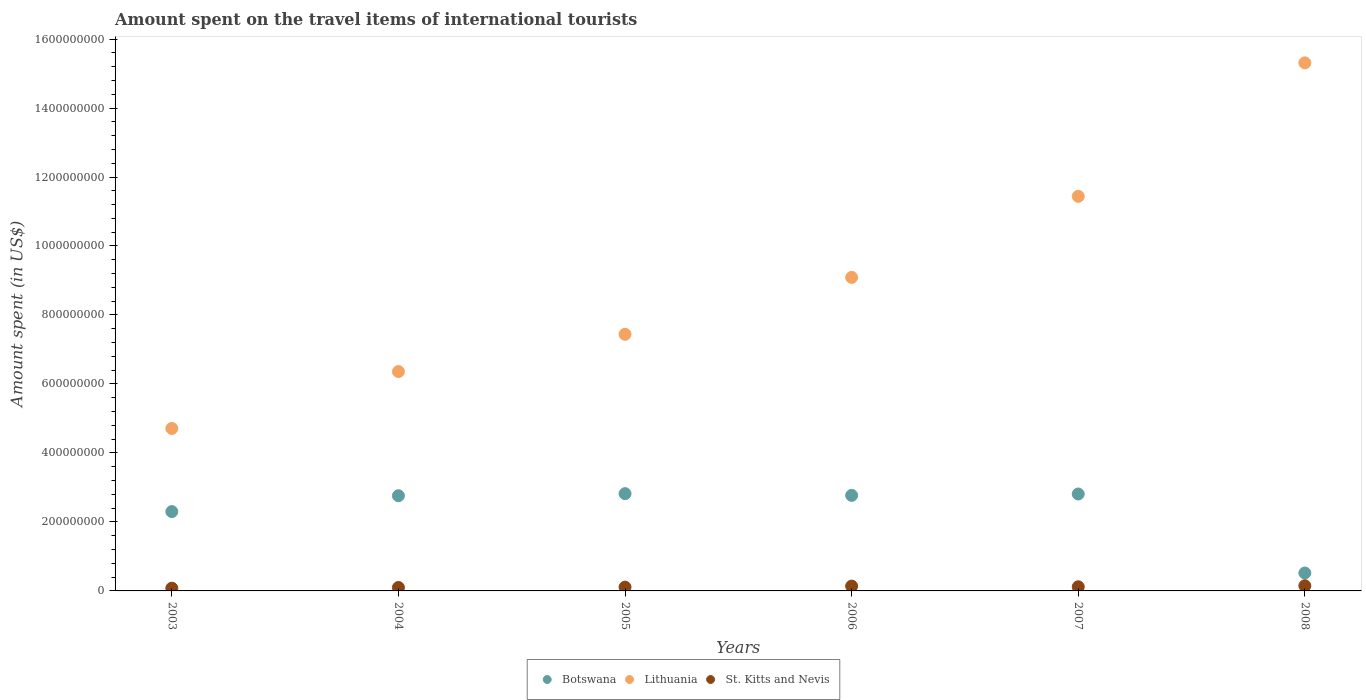Is the number of dotlines equal to the number of legend labels?
Provide a short and direct response. Yes. What is the amount spent on the travel items of international tourists in St. Kitts and Nevis in 2008?
Your response must be concise. 1.50e+07. Across all years, what is the maximum amount spent on the travel items of international tourists in Lithuania?
Your answer should be compact. 1.53e+09. Across all years, what is the minimum amount spent on the travel items of international tourists in Lithuania?
Provide a short and direct response. 4.71e+08. What is the total amount spent on the travel items of international tourists in Botswana in the graph?
Your answer should be compact. 1.40e+09. What is the difference between the amount spent on the travel items of international tourists in Lithuania in 2007 and that in 2008?
Offer a very short reply. -3.87e+08. What is the difference between the amount spent on the travel items of international tourists in Lithuania in 2004 and the amount spent on the travel items of international tourists in Botswana in 2005?
Offer a terse response. 3.54e+08. What is the average amount spent on the travel items of international tourists in Lithuania per year?
Keep it short and to the point. 9.06e+08. In the year 2007, what is the difference between the amount spent on the travel items of international tourists in Lithuania and amount spent on the travel items of international tourists in St. Kitts and Nevis?
Ensure brevity in your answer.  1.13e+09. In how many years, is the amount spent on the travel items of international tourists in Lithuania greater than 720000000 US$?
Your answer should be very brief. 4. What is the ratio of the amount spent on the travel items of international tourists in St. Kitts and Nevis in 2006 to that in 2008?
Make the answer very short. 0.93. Is the difference between the amount spent on the travel items of international tourists in Lithuania in 2003 and 2006 greater than the difference between the amount spent on the travel items of international tourists in St. Kitts and Nevis in 2003 and 2006?
Make the answer very short. No. What is the difference between the highest and the lowest amount spent on the travel items of international tourists in St. Kitts and Nevis?
Your answer should be very brief. 7.00e+06. How many dotlines are there?
Provide a succinct answer. 3. Are the values on the major ticks of Y-axis written in scientific E-notation?
Offer a very short reply. No. Does the graph contain any zero values?
Provide a short and direct response. No. Does the graph contain grids?
Offer a terse response. No. Where does the legend appear in the graph?
Offer a terse response. Bottom center. How many legend labels are there?
Make the answer very short. 3. How are the legend labels stacked?
Keep it short and to the point. Horizontal. What is the title of the graph?
Offer a terse response. Amount spent on the travel items of international tourists. What is the label or title of the Y-axis?
Make the answer very short. Amount spent (in US$). What is the Amount spent (in US$) of Botswana in 2003?
Give a very brief answer. 2.30e+08. What is the Amount spent (in US$) in Lithuania in 2003?
Make the answer very short. 4.71e+08. What is the Amount spent (in US$) of Botswana in 2004?
Give a very brief answer. 2.76e+08. What is the Amount spent (in US$) of Lithuania in 2004?
Keep it short and to the point. 6.36e+08. What is the Amount spent (in US$) of Botswana in 2005?
Provide a succinct answer. 2.82e+08. What is the Amount spent (in US$) in Lithuania in 2005?
Offer a very short reply. 7.44e+08. What is the Amount spent (in US$) in St. Kitts and Nevis in 2005?
Provide a short and direct response. 1.10e+07. What is the Amount spent (in US$) in Botswana in 2006?
Provide a short and direct response. 2.77e+08. What is the Amount spent (in US$) of Lithuania in 2006?
Give a very brief answer. 9.09e+08. What is the Amount spent (in US$) in St. Kitts and Nevis in 2006?
Give a very brief answer. 1.40e+07. What is the Amount spent (in US$) in Botswana in 2007?
Ensure brevity in your answer.  2.81e+08. What is the Amount spent (in US$) of Lithuania in 2007?
Provide a short and direct response. 1.14e+09. What is the Amount spent (in US$) in Botswana in 2008?
Your answer should be compact. 5.20e+07. What is the Amount spent (in US$) in Lithuania in 2008?
Keep it short and to the point. 1.53e+09. What is the Amount spent (in US$) in St. Kitts and Nevis in 2008?
Provide a succinct answer. 1.50e+07. Across all years, what is the maximum Amount spent (in US$) in Botswana?
Make the answer very short. 2.82e+08. Across all years, what is the maximum Amount spent (in US$) in Lithuania?
Your answer should be very brief. 1.53e+09. Across all years, what is the maximum Amount spent (in US$) of St. Kitts and Nevis?
Provide a short and direct response. 1.50e+07. Across all years, what is the minimum Amount spent (in US$) of Botswana?
Make the answer very short. 5.20e+07. Across all years, what is the minimum Amount spent (in US$) in Lithuania?
Make the answer very short. 4.71e+08. Across all years, what is the minimum Amount spent (in US$) in St. Kitts and Nevis?
Make the answer very short. 8.00e+06. What is the total Amount spent (in US$) in Botswana in the graph?
Provide a succinct answer. 1.40e+09. What is the total Amount spent (in US$) in Lithuania in the graph?
Offer a terse response. 5.44e+09. What is the total Amount spent (in US$) of St. Kitts and Nevis in the graph?
Provide a short and direct response. 7.00e+07. What is the difference between the Amount spent (in US$) in Botswana in 2003 and that in 2004?
Provide a succinct answer. -4.60e+07. What is the difference between the Amount spent (in US$) of Lithuania in 2003 and that in 2004?
Your answer should be compact. -1.65e+08. What is the difference between the Amount spent (in US$) of St. Kitts and Nevis in 2003 and that in 2004?
Your response must be concise. -2.00e+06. What is the difference between the Amount spent (in US$) of Botswana in 2003 and that in 2005?
Provide a succinct answer. -5.20e+07. What is the difference between the Amount spent (in US$) of Lithuania in 2003 and that in 2005?
Your response must be concise. -2.73e+08. What is the difference between the Amount spent (in US$) in Botswana in 2003 and that in 2006?
Provide a short and direct response. -4.70e+07. What is the difference between the Amount spent (in US$) of Lithuania in 2003 and that in 2006?
Provide a short and direct response. -4.38e+08. What is the difference between the Amount spent (in US$) of St. Kitts and Nevis in 2003 and that in 2006?
Give a very brief answer. -6.00e+06. What is the difference between the Amount spent (in US$) in Botswana in 2003 and that in 2007?
Keep it short and to the point. -5.10e+07. What is the difference between the Amount spent (in US$) of Lithuania in 2003 and that in 2007?
Your response must be concise. -6.73e+08. What is the difference between the Amount spent (in US$) in St. Kitts and Nevis in 2003 and that in 2007?
Your answer should be compact. -4.00e+06. What is the difference between the Amount spent (in US$) of Botswana in 2003 and that in 2008?
Make the answer very short. 1.78e+08. What is the difference between the Amount spent (in US$) of Lithuania in 2003 and that in 2008?
Your answer should be compact. -1.06e+09. What is the difference between the Amount spent (in US$) in St. Kitts and Nevis in 2003 and that in 2008?
Your response must be concise. -7.00e+06. What is the difference between the Amount spent (in US$) of Botswana in 2004 and that in 2005?
Provide a short and direct response. -6.00e+06. What is the difference between the Amount spent (in US$) of Lithuania in 2004 and that in 2005?
Provide a succinct answer. -1.08e+08. What is the difference between the Amount spent (in US$) in St. Kitts and Nevis in 2004 and that in 2005?
Ensure brevity in your answer.  -1.00e+06. What is the difference between the Amount spent (in US$) in Lithuania in 2004 and that in 2006?
Make the answer very short. -2.73e+08. What is the difference between the Amount spent (in US$) in St. Kitts and Nevis in 2004 and that in 2006?
Give a very brief answer. -4.00e+06. What is the difference between the Amount spent (in US$) of Botswana in 2004 and that in 2007?
Offer a terse response. -5.00e+06. What is the difference between the Amount spent (in US$) in Lithuania in 2004 and that in 2007?
Make the answer very short. -5.08e+08. What is the difference between the Amount spent (in US$) of St. Kitts and Nevis in 2004 and that in 2007?
Your answer should be compact. -2.00e+06. What is the difference between the Amount spent (in US$) in Botswana in 2004 and that in 2008?
Offer a very short reply. 2.24e+08. What is the difference between the Amount spent (in US$) of Lithuania in 2004 and that in 2008?
Provide a succinct answer. -8.95e+08. What is the difference between the Amount spent (in US$) of St. Kitts and Nevis in 2004 and that in 2008?
Provide a short and direct response. -5.00e+06. What is the difference between the Amount spent (in US$) of Botswana in 2005 and that in 2006?
Your answer should be compact. 5.00e+06. What is the difference between the Amount spent (in US$) of Lithuania in 2005 and that in 2006?
Give a very brief answer. -1.65e+08. What is the difference between the Amount spent (in US$) in Botswana in 2005 and that in 2007?
Your answer should be very brief. 1.00e+06. What is the difference between the Amount spent (in US$) of Lithuania in 2005 and that in 2007?
Ensure brevity in your answer.  -4.00e+08. What is the difference between the Amount spent (in US$) in Botswana in 2005 and that in 2008?
Offer a terse response. 2.30e+08. What is the difference between the Amount spent (in US$) in Lithuania in 2005 and that in 2008?
Give a very brief answer. -7.87e+08. What is the difference between the Amount spent (in US$) of St. Kitts and Nevis in 2005 and that in 2008?
Ensure brevity in your answer.  -4.00e+06. What is the difference between the Amount spent (in US$) of Botswana in 2006 and that in 2007?
Your response must be concise. -4.00e+06. What is the difference between the Amount spent (in US$) in Lithuania in 2006 and that in 2007?
Provide a short and direct response. -2.35e+08. What is the difference between the Amount spent (in US$) of Botswana in 2006 and that in 2008?
Give a very brief answer. 2.25e+08. What is the difference between the Amount spent (in US$) of Lithuania in 2006 and that in 2008?
Make the answer very short. -6.22e+08. What is the difference between the Amount spent (in US$) of St. Kitts and Nevis in 2006 and that in 2008?
Your answer should be very brief. -1.00e+06. What is the difference between the Amount spent (in US$) of Botswana in 2007 and that in 2008?
Your answer should be very brief. 2.29e+08. What is the difference between the Amount spent (in US$) of Lithuania in 2007 and that in 2008?
Make the answer very short. -3.87e+08. What is the difference between the Amount spent (in US$) of St. Kitts and Nevis in 2007 and that in 2008?
Offer a terse response. -3.00e+06. What is the difference between the Amount spent (in US$) in Botswana in 2003 and the Amount spent (in US$) in Lithuania in 2004?
Provide a succinct answer. -4.06e+08. What is the difference between the Amount spent (in US$) in Botswana in 2003 and the Amount spent (in US$) in St. Kitts and Nevis in 2004?
Provide a succinct answer. 2.20e+08. What is the difference between the Amount spent (in US$) in Lithuania in 2003 and the Amount spent (in US$) in St. Kitts and Nevis in 2004?
Provide a short and direct response. 4.61e+08. What is the difference between the Amount spent (in US$) of Botswana in 2003 and the Amount spent (in US$) of Lithuania in 2005?
Your answer should be very brief. -5.14e+08. What is the difference between the Amount spent (in US$) in Botswana in 2003 and the Amount spent (in US$) in St. Kitts and Nevis in 2005?
Your answer should be very brief. 2.19e+08. What is the difference between the Amount spent (in US$) in Lithuania in 2003 and the Amount spent (in US$) in St. Kitts and Nevis in 2005?
Offer a terse response. 4.60e+08. What is the difference between the Amount spent (in US$) in Botswana in 2003 and the Amount spent (in US$) in Lithuania in 2006?
Provide a short and direct response. -6.79e+08. What is the difference between the Amount spent (in US$) in Botswana in 2003 and the Amount spent (in US$) in St. Kitts and Nevis in 2006?
Your answer should be very brief. 2.16e+08. What is the difference between the Amount spent (in US$) of Lithuania in 2003 and the Amount spent (in US$) of St. Kitts and Nevis in 2006?
Your answer should be compact. 4.57e+08. What is the difference between the Amount spent (in US$) in Botswana in 2003 and the Amount spent (in US$) in Lithuania in 2007?
Your answer should be compact. -9.14e+08. What is the difference between the Amount spent (in US$) in Botswana in 2003 and the Amount spent (in US$) in St. Kitts and Nevis in 2007?
Your answer should be compact. 2.18e+08. What is the difference between the Amount spent (in US$) of Lithuania in 2003 and the Amount spent (in US$) of St. Kitts and Nevis in 2007?
Offer a very short reply. 4.59e+08. What is the difference between the Amount spent (in US$) of Botswana in 2003 and the Amount spent (in US$) of Lithuania in 2008?
Your answer should be compact. -1.30e+09. What is the difference between the Amount spent (in US$) of Botswana in 2003 and the Amount spent (in US$) of St. Kitts and Nevis in 2008?
Provide a short and direct response. 2.15e+08. What is the difference between the Amount spent (in US$) of Lithuania in 2003 and the Amount spent (in US$) of St. Kitts and Nevis in 2008?
Make the answer very short. 4.56e+08. What is the difference between the Amount spent (in US$) in Botswana in 2004 and the Amount spent (in US$) in Lithuania in 2005?
Give a very brief answer. -4.68e+08. What is the difference between the Amount spent (in US$) of Botswana in 2004 and the Amount spent (in US$) of St. Kitts and Nevis in 2005?
Give a very brief answer. 2.65e+08. What is the difference between the Amount spent (in US$) in Lithuania in 2004 and the Amount spent (in US$) in St. Kitts and Nevis in 2005?
Ensure brevity in your answer.  6.25e+08. What is the difference between the Amount spent (in US$) of Botswana in 2004 and the Amount spent (in US$) of Lithuania in 2006?
Offer a terse response. -6.33e+08. What is the difference between the Amount spent (in US$) in Botswana in 2004 and the Amount spent (in US$) in St. Kitts and Nevis in 2006?
Offer a very short reply. 2.62e+08. What is the difference between the Amount spent (in US$) in Lithuania in 2004 and the Amount spent (in US$) in St. Kitts and Nevis in 2006?
Give a very brief answer. 6.22e+08. What is the difference between the Amount spent (in US$) in Botswana in 2004 and the Amount spent (in US$) in Lithuania in 2007?
Offer a very short reply. -8.68e+08. What is the difference between the Amount spent (in US$) of Botswana in 2004 and the Amount spent (in US$) of St. Kitts and Nevis in 2007?
Provide a succinct answer. 2.64e+08. What is the difference between the Amount spent (in US$) of Lithuania in 2004 and the Amount spent (in US$) of St. Kitts and Nevis in 2007?
Offer a terse response. 6.24e+08. What is the difference between the Amount spent (in US$) in Botswana in 2004 and the Amount spent (in US$) in Lithuania in 2008?
Provide a succinct answer. -1.26e+09. What is the difference between the Amount spent (in US$) in Botswana in 2004 and the Amount spent (in US$) in St. Kitts and Nevis in 2008?
Ensure brevity in your answer.  2.61e+08. What is the difference between the Amount spent (in US$) of Lithuania in 2004 and the Amount spent (in US$) of St. Kitts and Nevis in 2008?
Your answer should be compact. 6.21e+08. What is the difference between the Amount spent (in US$) in Botswana in 2005 and the Amount spent (in US$) in Lithuania in 2006?
Offer a terse response. -6.27e+08. What is the difference between the Amount spent (in US$) of Botswana in 2005 and the Amount spent (in US$) of St. Kitts and Nevis in 2006?
Offer a terse response. 2.68e+08. What is the difference between the Amount spent (in US$) in Lithuania in 2005 and the Amount spent (in US$) in St. Kitts and Nevis in 2006?
Offer a terse response. 7.30e+08. What is the difference between the Amount spent (in US$) of Botswana in 2005 and the Amount spent (in US$) of Lithuania in 2007?
Your answer should be very brief. -8.62e+08. What is the difference between the Amount spent (in US$) of Botswana in 2005 and the Amount spent (in US$) of St. Kitts and Nevis in 2007?
Keep it short and to the point. 2.70e+08. What is the difference between the Amount spent (in US$) of Lithuania in 2005 and the Amount spent (in US$) of St. Kitts and Nevis in 2007?
Give a very brief answer. 7.32e+08. What is the difference between the Amount spent (in US$) of Botswana in 2005 and the Amount spent (in US$) of Lithuania in 2008?
Your answer should be very brief. -1.25e+09. What is the difference between the Amount spent (in US$) of Botswana in 2005 and the Amount spent (in US$) of St. Kitts and Nevis in 2008?
Provide a succinct answer. 2.67e+08. What is the difference between the Amount spent (in US$) of Lithuania in 2005 and the Amount spent (in US$) of St. Kitts and Nevis in 2008?
Ensure brevity in your answer.  7.29e+08. What is the difference between the Amount spent (in US$) in Botswana in 2006 and the Amount spent (in US$) in Lithuania in 2007?
Your response must be concise. -8.67e+08. What is the difference between the Amount spent (in US$) in Botswana in 2006 and the Amount spent (in US$) in St. Kitts and Nevis in 2007?
Give a very brief answer. 2.65e+08. What is the difference between the Amount spent (in US$) in Lithuania in 2006 and the Amount spent (in US$) in St. Kitts and Nevis in 2007?
Your answer should be compact. 8.97e+08. What is the difference between the Amount spent (in US$) of Botswana in 2006 and the Amount spent (in US$) of Lithuania in 2008?
Give a very brief answer. -1.25e+09. What is the difference between the Amount spent (in US$) of Botswana in 2006 and the Amount spent (in US$) of St. Kitts and Nevis in 2008?
Give a very brief answer. 2.62e+08. What is the difference between the Amount spent (in US$) in Lithuania in 2006 and the Amount spent (in US$) in St. Kitts and Nevis in 2008?
Offer a very short reply. 8.94e+08. What is the difference between the Amount spent (in US$) in Botswana in 2007 and the Amount spent (in US$) in Lithuania in 2008?
Your answer should be compact. -1.25e+09. What is the difference between the Amount spent (in US$) of Botswana in 2007 and the Amount spent (in US$) of St. Kitts and Nevis in 2008?
Make the answer very short. 2.66e+08. What is the difference between the Amount spent (in US$) in Lithuania in 2007 and the Amount spent (in US$) in St. Kitts and Nevis in 2008?
Make the answer very short. 1.13e+09. What is the average Amount spent (in US$) in Botswana per year?
Provide a short and direct response. 2.33e+08. What is the average Amount spent (in US$) of Lithuania per year?
Offer a very short reply. 9.06e+08. What is the average Amount spent (in US$) in St. Kitts and Nevis per year?
Make the answer very short. 1.17e+07. In the year 2003, what is the difference between the Amount spent (in US$) of Botswana and Amount spent (in US$) of Lithuania?
Make the answer very short. -2.41e+08. In the year 2003, what is the difference between the Amount spent (in US$) of Botswana and Amount spent (in US$) of St. Kitts and Nevis?
Your answer should be very brief. 2.22e+08. In the year 2003, what is the difference between the Amount spent (in US$) in Lithuania and Amount spent (in US$) in St. Kitts and Nevis?
Give a very brief answer. 4.63e+08. In the year 2004, what is the difference between the Amount spent (in US$) in Botswana and Amount spent (in US$) in Lithuania?
Provide a succinct answer. -3.60e+08. In the year 2004, what is the difference between the Amount spent (in US$) in Botswana and Amount spent (in US$) in St. Kitts and Nevis?
Ensure brevity in your answer.  2.66e+08. In the year 2004, what is the difference between the Amount spent (in US$) in Lithuania and Amount spent (in US$) in St. Kitts and Nevis?
Your answer should be very brief. 6.26e+08. In the year 2005, what is the difference between the Amount spent (in US$) in Botswana and Amount spent (in US$) in Lithuania?
Provide a short and direct response. -4.62e+08. In the year 2005, what is the difference between the Amount spent (in US$) in Botswana and Amount spent (in US$) in St. Kitts and Nevis?
Offer a very short reply. 2.71e+08. In the year 2005, what is the difference between the Amount spent (in US$) in Lithuania and Amount spent (in US$) in St. Kitts and Nevis?
Offer a terse response. 7.33e+08. In the year 2006, what is the difference between the Amount spent (in US$) in Botswana and Amount spent (in US$) in Lithuania?
Offer a terse response. -6.32e+08. In the year 2006, what is the difference between the Amount spent (in US$) of Botswana and Amount spent (in US$) of St. Kitts and Nevis?
Keep it short and to the point. 2.63e+08. In the year 2006, what is the difference between the Amount spent (in US$) of Lithuania and Amount spent (in US$) of St. Kitts and Nevis?
Provide a succinct answer. 8.95e+08. In the year 2007, what is the difference between the Amount spent (in US$) in Botswana and Amount spent (in US$) in Lithuania?
Ensure brevity in your answer.  -8.63e+08. In the year 2007, what is the difference between the Amount spent (in US$) in Botswana and Amount spent (in US$) in St. Kitts and Nevis?
Provide a succinct answer. 2.69e+08. In the year 2007, what is the difference between the Amount spent (in US$) of Lithuania and Amount spent (in US$) of St. Kitts and Nevis?
Ensure brevity in your answer.  1.13e+09. In the year 2008, what is the difference between the Amount spent (in US$) in Botswana and Amount spent (in US$) in Lithuania?
Make the answer very short. -1.48e+09. In the year 2008, what is the difference between the Amount spent (in US$) in Botswana and Amount spent (in US$) in St. Kitts and Nevis?
Provide a succinct answer. 3.70e+07. In the year 2008, what is the difference between the Amount spent (in US$) in Lithuania and Amount spent (in US$) in St. Kitts and Nevis?
Offer a very short reply. 1.52e+09. What is the ratio of the Amount spent (in US$) in Lithuania in 2003 to that in 2004?
Ensure brevity in your answer.  0.74. What is the ratio of the Amount spent (in US$) in St. Kitts and Nevis in 2003 to that in 2004?
Keep it short and to the point. 0.8. What is the ratio of the Amount spent (in US$) in Botswana in 2003 to that in 2005?
Your response must be concise. 0.82. What is the ratio of the Amount spent (in US$) in Lithuania in 2003 to that in 2005?
Provide a succinct answer. 0.63. What is the ratio of the Amount spent (in US$) in St. Kitts and Nevis in 2003 to that in 2005?
Keep it short and to the point. 0.73. What is the ratio of the Amount spent (in US$) in Botswana in 2003 to that in 2006?
Give a very brief answer. 0.83. What is the ratio of the Amount spent (in US$) in Lithuania in 2003 to that in 2006?
Offer a very short reply. 0.52. What is the ratio of the Amount spent (in US$) of St. Kitts and Nevis in 2003 to that in 2006?
Your response must be concise. 0.57. What is the ratio of the Amount spent (in US$) in Botswana in 2003 to that in 2007?
Provide a succinct answer. 0.82. What is the ratio of the Amount spent (in US$) of Lithuania in 2003 to that in 2007?
Offer a terse response. 0.41. What is the ratio of the Amount spent (in US$) of Botswana in 2003 to that in 2008?
Keep it short and to the point. 4.42. What is the ratio of the Amount spent (in US$) in Lithuania in 2003 to that in 2008?
Provide a short and direct response. 0.31. What is the ratio of the Amount spent (in US$) in St. Kitts and Nevis in 2003 to that in 2008?
Provide a succinct answer. 0.53. What is the ratio of the Amount spent (in US$) of Botswana in 2004 to that in 2005?
Provide a succinct answer. 0.98. What is the ratio of the Amount spent (in US$) of Lithuania in 2004 to that in 2005?
Your response must be concise. 0.85. What is the ratio of the Amount spent (in US$) in St. Kitts and Nevis in 2004 to that in 2005?
Keep it short and to the point. 0.91. What is the ratio of the Amount spent (in US$) of Botswana in 2004 to that in 2006?
Provide a succinct answer. 1. What is the ratio of the Amount spent (in US$) in Lithuania in 2004 to that in 2006?
Offer a terse response. 0.7. What is the ratio of the Amount spent (in US$) of Botswana in 2004 to that in 2007?
Your response must be concise. 0.98. What is the ratio of the Amount spent (in US$) of Lithuania in 2004 to that in 2007?
Provide a short and direct response. 0.56. What is the ratio of the Amount spent (in US$) in St. Kitts and Nevis in 2004 to that in 2007?
Provide a short and direct response. 0.83. What is the ratio of the Amount spent (in US$) of Botswana in 2004 to that in 2008?
Give a very brief answer. 5.31. What is the ratio of the Amount spent (in US$) of Lithuania in 2004 to that in 2008?
Your answer should be compact. 0.42. What is the ratio of the Amount spent (in US$) of Botswana in 2005 to that in 2006?
Provide a short and direct response. 1.02. What is the ratio of the Amount spent (in US$) in Lithuania in 2005 to that in 2006?
Provide a short and direct response. 0.82. What is the ratio of the Amount spent (in US$) of St. Kitts and Nevis in 2005 to that in 2006?
Make the answer very short. 0.79. What is the ratio of the Amount spent (in US$) of Lithuania in 2005 to that in 2007?
Your answer should be compact. 0.65. What is the ratio of the Amount spent (in US$) of St. Kitts and Nevis in 2005 to that in 2007?
Offer a very short reply. 0.92. What is the ratio of the Amount spent (in US$) of Botswana in 2005 to that in 2008?
Your answer should be very brief. 5.42. What is the ratio of the Amount spent (in US$) in Lithuania in 2005 to that in 2008?
Your response must be concise. 0.49. What is the ratio of the Amount spent (in US$) in St. Kitts and Nevis in 2005 to that in 2008?
Your answer should be very brief. 0.73. What is the ratio of the Amount spent (in US$) of Botswana in 2006 to that in 2007?
Offer a terse response. 0.99. What is the ratio of the Amount spent (in US$) of Lithuania in 2006 to that in 2007?
Offer a very short reply. 0.79. What is the ratio of the Amount spent (in US$) of Botswana in 2006 to that in 2008?
Give a very brief answer. 5.33. What is the ratio of the Amount spent (in US$) in Lithuania in 2006 to that in 2008?
Your answer should be compact. 0.59. What is the ratio of the Amount spent (in US$) in Botswana in 2007 to that in 2008?
Make the answer very short. 5.4. What is the ratio of the Amount spent (in US$) in Lithuania in 2007 to that in 2008?
Ensure brevity in your answer.  0.75. What is the ratio of the Amount spent (in US$) in St. Kitts and Nevis in 2007 to that in 2008?
Your answer should be compact. 0.8. What is the difference between the highest and the second highest Amount spent (in US$) of Lithuania?
Your answer should be very brief. 3.87e+08. What is the difference between the highest and the second highest Amount spent (in US$) in St. Kitts and Nevis?
Offer a terse response. 1.00e+06. What is the difference between the highest and the lowest Amount spent (in US$) in Botswana?
Your response must be concise. 2.30e+08. What is the difference between the highest and the lowest Amount spent (in US$) in Lithuania?
Offer a very short reply. 1.06e+09. 